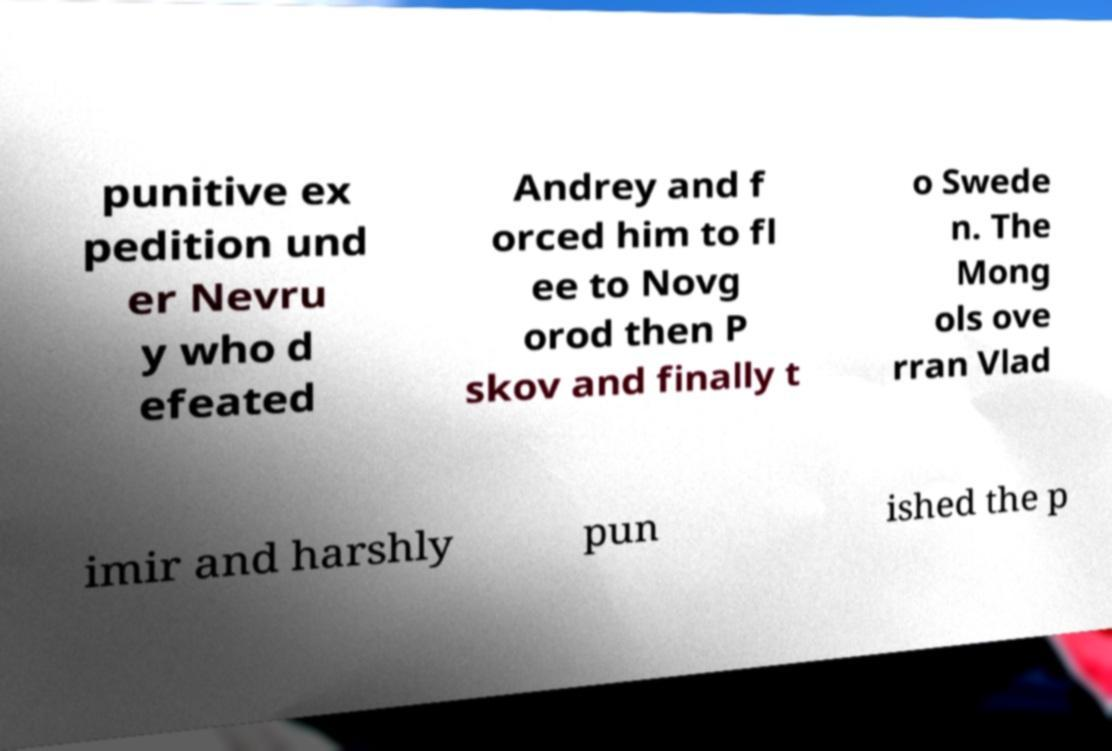Can you read and provide the text displayed in the image?This photo seems to have some interesting text. Can you extract and type it out for me? punitive ex pedition und er Nevru y who d efeated Andrey and f orced him to fl ee to Novg orod then P skov and finally t o Swede n. The Mong ols ove rran Vlad imir and harshly pun ished the p 